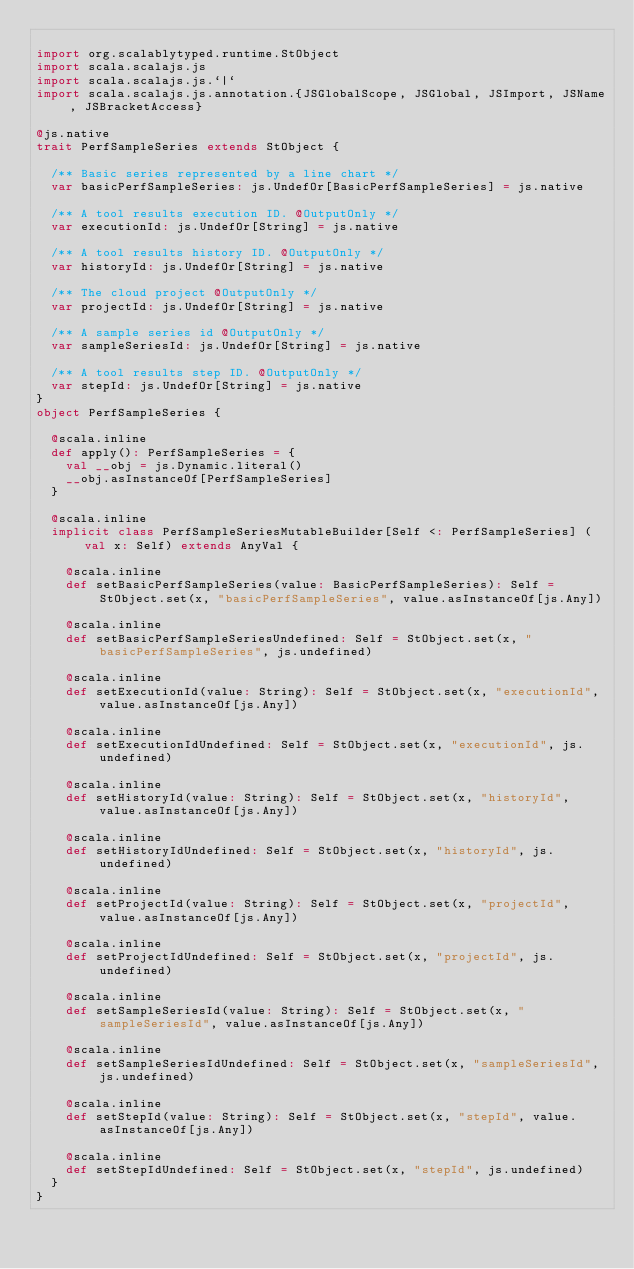<code> <loc_0><loc_0><loc_500><loc_500><_Scala_>
import org.scalablytyped.runtime.StObject
import scala.scalajs.js
import scala.scalajs.js.`|`
import scala.scalajs.js.annotation.{JSGlobalScope, JSGlobal, JSImport, JSName, JSBracketAccess}

@js.native
trait PerfSampleSeries extends StObject {
  
  /** Basic series represented by a line chart */
  var basicPerfSampleSeries: js.UndefOr[BasicPerfSampleSeries] = js.native
  
  /** A tool results execution ID. @OutputOnly */
  var executionId: js.UndefOr[String] = js.native
  
  /** A tool results history ID. @OutputOnly */
  var historyId: js.UndefOr[String] = js.native
  
  /** The cloud project @OutputOnly */
  var projectId: js.UndefOr[String] = js.native
  
  /** A sample series id @OutputOnly */
  var sampleSeriesId: js.UndefOr[String] = js.native
  
  /** A tool results step ID. @OutputOnly */
  var stepId: js.UndefOr[String] = js.native
}
object PerfSampleSeries {
  
  @scala.inline
  def apply(): PerfSampleSeries = {
    val __obj = js.Dynamic.literal()
    __obj.asInstanceOf[PerfSampleSeries]
  }
  
  @scala.inline
  implicit class PerfSampleSeriesMutableBuilder[Self <: PerfSampleSeries] (val x: Self) extends AnyVal {
    
    @scala.inline
    def setBasicPerfSampleSeries(value: BasicPerfSampleSeries): Self = StObject.set(x, "basicPerfSampleSeries", value.asInstanceOf[js.Any])
    
    @scala.inline
    def setBasicPerfSampleSeriesUndefined: Self = StObject.set(x, "basicPerfSampleSeries", js.undefined)
    
    @scala.inline
    def setExecutionId(value: String): Self = StObject.set(x, "executionId", value.asInstanceOf[js.Any])
    
    @scala.inline
    def setExecutionIdUndefined: Self = StObject.set(x, "executionId", js.undefined)
    
    @scala.inline
    def setHistoryId(value: String): Self = StObject.set(x, "historyId", value.asInstanceOf[js.Any])
    
    @scala.inline
    def setHistoryIdUndefined: Self = StObject.set(x, "historyId", js.undefined)
    
    @scala.inline
    def setProjectId(value: String): Self = StObject.set(x, "projectId", value.asInstanceOf[js.Any])
    
    @scala.inline
    def setProjectIdUndefined: Self = StObject.set(x, "projectId", js.undefined)
    
    @scala.inline
    def setSampleSeriesId(value: String): Self = StObject.set(x, "sampleSeriesId", value.asInstanceOf[js.Any])
    
    @scala.inline
    def setSampleSeriesIdUndefined: Self = StObject.set(x, "sampleSeriesId", js.undefined)
    
    @scala.inline
    def setStepId(value: String): Self = StObject.set(x, "stepId", value.asInstanceOf[js.Any])
    
    @scala.inline
    def setStepIdUndefined: Self = StObject.set(x, "stepId", js.undefined)
  }
}
</code> 